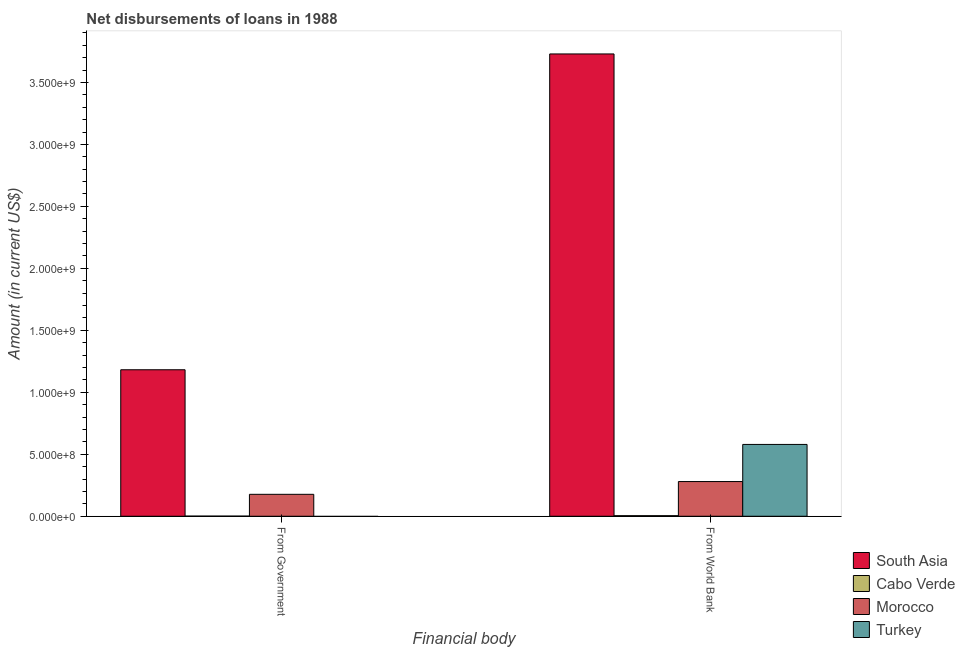How many different coloured bars are there?
Provide a short and direct response. 4. Are the number of bars on each tick of the X-axis equal?
Your answer should be very brief. No. How many bars are there on the 1st tick from the left?
Ensure brevity in your answer.  3. What is the label of the 1st group of bars from the left?
Provide a short and direct response. From Government. What is the net disbursements of loan from world bank in South Asia?
Your answer should be very brief. 3.73e+09. Across all countries, what is the maximum net disbursements of loan from world bank?
Your response must be concise. 3.73e+09. Across all countries, what is the minimum net disbursements of loan from government?
Keep it short and to the point. 0. What is the total net disbursements of loan from world bank in the graph?
Your response must be concise. 4.59e+09. What is the difference between the net disbursements of loan from world bank in Morocco and that in Turkey?
Offer a very short reply. -3.00e+08. What is the difference between the net disbursements of loan from world bank in Morocco and the net disbursements of loan from government in South Asia?
Offer a terse response. -9.02e+08. What is the average net disbursements of loan from government per country?
Offer a terse response. 3.40e+08. What is the difference between the net disbursements of loan from world bank and net disbursements of loan from government in South Asia?
Make the answer very short. 2.55e+09. What is the ratio of the net disbursements of loan from government in Cabo Verde to that in Morocco?
Offer a very short reply. 0.01. Is the net disbursements of loan from world bank in South Asia less than that in Cabo Verde?
Ensure brevity in your answer.  No. In how many countries, is the net disbursements of loan from world bank greater than the average net disbursements of loan from world bank taken over all countries?
Give a very brief answer. 1. Are all the bars in the graph horizontal?
Offer a very short reply. No. Does the graph contain grids?
Offer a terse response. No. Where does the legend appear in the graph?
Your answer should be compact. Bottom right. How are the legend labels stacked?
Offer a very short reply. Vertical. What is the title of the graph?
Your response must be concise. Net disbursements of loans in 1988. What is the label or title of the X-axis?
Provide a succinct answer. Financial body. What is the Amount (in current US$) in South Asia in From Government?
Your answer should be compact. 1.18e+09. What is the Amount (in current US$) of Cabo Verde in From Government?
Make the answer very short. 1.06e+06. What is the Amount (in current US$) in Morocco in From Government?
Your answer should be compact. 1.77e+08. What is the Amount (in current US$) in South Asia in From World Bank?
Keep it short and to the point. 3.73e+09. What is the Amount (in current US$) of Cabo Verde in From World Bank?
Ensure brevity in your answer.  4.68e+06. What is the Amount (in current US$) of Morocco in From World Bank?
Keep it short and to the point. 2.80e+08. What is the Amount (in current US$) of Turkey in From World Bank?
Offer a very short reply. 5.79e+08. Across all Financial body, what is the maximum Amount (in current US$) in South Asia?
Your answer should be very brief. 3.73e+09. Across all Financial body, what is the maximum Amount (in current US$) in Cabo Verde?
Your answer should be very brief. 4.68e+06. Across all Financial body, what is the maximum Amount (in current US$) of Morocco?
Provide a succinct answer. 2.80e+08. Across all Financial body, what is the maximum Amount (in current US$) in Turkey?
Keep it short and to the point. 5.79e+08. Across all Financial body, what is the minimum Amount (in current US$) in South Asia?
Offer a terse response. 1.18e+09. Across all Financial body, what is the minimum Amount (in current US$) of Cabo Verde?
Give a very brief answer. 1.06e+06. Across all Financial body, what is the minimum Amount (in current US$) in Morocco?
Keep it short and to the point. 1.77e+08. Across all Financial body, what is the minimum Amount (in current US$) of Turkey?
Your response must be concise. 0. What is the total Amount (in current US$) of South Asia in the graph?
Make the answer very short. 4.91e+09. What is the total Amount (in current US$) in Cabo Verde in the graph?
Give a very brief answer. 5.73e+06. What is the total Amount (in current US$) of Morocco in the graph?
Provide a succinct answer. 4.57e+08. What is the total Amount (in current US$) in Turkey in the graph?
Your answer should be compact. 5.79e+08. What is the difference between the Amount (in current US$) in South Asia in From Government and that in From World Bank?
Your answer should be very brief. -2.55e+09. What is the difference between the Amount (in current US$) of Cabo Verde in From Government and that in From World Bank?
Keep it short and to the point. -3.62e+06. What is the difference between the Amount (in current US$) in Morocco in From Government and that in From World Bank?
Provide a succinct answer. -1.03e+08. What is the difference between the Amount (in current US$) of South Asia in From Government and the Amount (in current US$) of Cabo Verde in From World Bank?
Your response must be concise. 1.18e+09. What is the difference between the Amount (in current US$) of South Asia in From Government and the Amount (in current US$) of Morocco in From World Bank?
Provide a short and direct response. 9.02e+08. What is the difference between the Amount (in current US$) in South Asia in From Government and the Amount (in current US$) in Turkey in From World Bank?
Your answer should be compact. 6.02e+08. What is the difference between the Amount (in current US$) of Cabo Verde in From Government and the Amount (in current US$) of Morocco in From World Bank?
Provide a short and direct response. -2.79e+08. What is the difference between the Amount (in current US$) of Cabo Verde in From Government and the Amount (in current US$) of Turkey in From World Bank?
Make the answer very short. -5.78e+08. What is the difference between the Amount (in current US$) in Morocco in From Government and the Amount (in current US$) in Turkey in From World Bank?
Offer a terse response. -4.03e+08. What is the average Amount (in current US$) of South Asia per Financial body?
Keep it short and to the point. 2.46e+09. What is the average Amount (in current US$) of Cabo Verde per Financial body?
Offer a very short reply. 2.87e+06. What is the average Amount (in current US$) in Morocco per Financial body?
Provide a succinct answer. 2.28e+08. What is the average Amount (in current US$) of Turkey per Financial body?
Your answer should be compact. 2.90e+08. What is the difference between the Amount (in current US$) in South Asia and Amount (in current US$) in Cabo Verde in From Government?
Offer a very short reply. 1.18e+09. What is the difference between the Amount (in current US$) in South Asia and Amount (in current US$) in Morocco in From Government?
Your answer should be very brief. 1.00e+09. What is the difference between the Amount (in current US$) of Cabo Verde and Amount (in current US$) of Morocco in From Government?
Provide a short and direct response. -1.76e+08. What is the difference between the Amount (in current US$) in South Asia and Amount (in current US$) in Cabo Verde in From World Bank?
Offer a very short reply. 3.73e+09. What is the difference between the Amount (in current US$) in South Asia and Amount (in current US$) in Morocco in From World Bank?
Offer a very short reply. 3.45e+09. What is the difference between the Amount (in current US$) in South Asia and Amount (in current US$) in Turkey in From World Bank?
Offer a very short reply. 3.15e+09. What is the difference between the Amount (in current US$) in Cabo Verde and Amount (in current US$) in Morocco in From World Bank?
Your response must be concise. -2.75e+08. What is the difference between the Amount (in current US$) in Cabo Verde and Amount (in current US$) in Turkey in From World Bank?
Provide a short and direct response. -5.75e+08. What is the difference between the Amount (in current US$) in Morocco and Amount (in current US$) in Turkey in From World Bank?
Provide a short and direct response. -3.00e+08. What is the ratio of the Amount (in current US$) in South Asia in From Government to that in From World Bank?
Offer a very short reply. 0.32. What is the ratio of the Amount (in current US$) of Cabo Verde in From Government to that in From World Bank?
Keep it short and to the point. 0.23. What is the ratio of the Amount (in current US$) in Morocco in From Government to that in From World Bank?
Offer a very short reply. 0.63. What is the difference between the highest and the second highest Amount (in current US$) of South Asia?
Give a very brief answer. 2.55e+09. What is the difference between the highest and the second highest Amount (in current US$) in Cabo Verde?
Provide a succinct answer. 3.62e+06. What is the difference between the highest and the second highest Amount (in current US$) of Morocco?
Your answer should be compact. 1.03e+08. What is the difference between the highest and the lowest Amount (in current US$) in South Asia?
Make the answer very short. 2.55e+09. What is the difference between the highest and the lowest Amount (in current US$) of Cabo Verde?
Keep it short and to the point. 3.62e+06. What is the difference between the highest and the lowest Amount (in current US$) in Morocco?
Provide a short and direct response. 1.03e+08. What is the difference between the highest and the lowest Amount (in current US$) in Turkey?
Provide a succinct answer. 5.79e+08. 